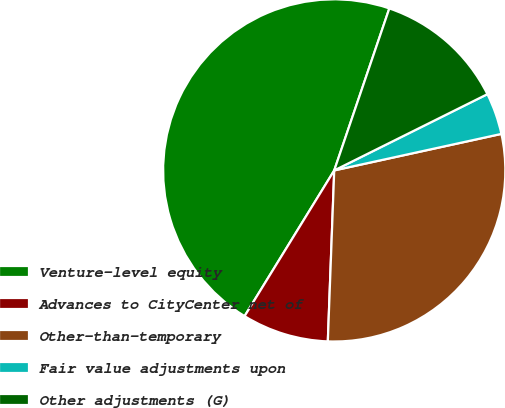Convert chart to OTSL. <chart><loc_0><loc_0><loc_500><loc_500><pie_chart><fcel>Venture-level equity<fcel>Advances to CityCenter net of<fcel>Other-than-temporary<fcel>Fair value adjustments upon<fcel>Other adjustments (G)<nl><fcel>46.44%<fcel>8.18%<fcel>29.02%<fcel>3.93%<fcel>12.43%<nl></chart> 